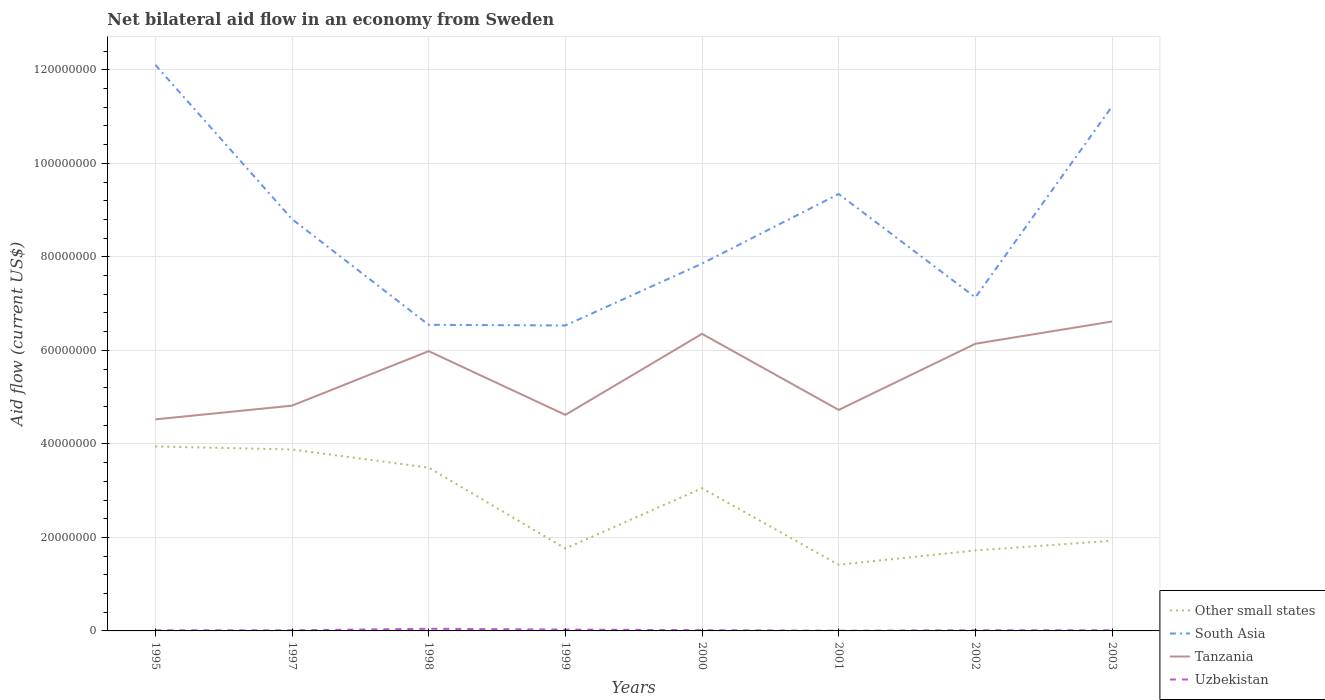Does the line corresponding to Uzbekistan intersect with the line corresponding to South Asia?
Keep it short and to the point. No. Across all years, what is the maximum net bilateral aid flow in Uzbekistan?
Provide a succinct answer. 4.00e+04. What is the total net bilateral aid flow in Other small states in the graph?
Offer a terse response. 1.73e+07. What is the difference between the highest and the second highest net bilateral aid flow in Tanzania?
Make the answer very short. 2.09e+07. Is the net bilateral aid flow in Uzbekistan strictly greater than the net bilateral aid flow in South Asia over the years?
Ensure brevity in your answer.  Yes. What is the difference between two consecutive major ticks on the Y-axis?
Give a very brief answer. 2.00e+07. Are the values on the major ticks of Y-axis written in scientific E-notation?
Your response must be concise. No. Does the graph contain grids?
Provide a short and direct response. Yes. Where does the legend appear in the graph?
Provide a short and direct response. Bottom right. How many legend labels are there?
Offer a very short reply. 4. How are the legend labels stacked?
Offer a very short reply. Vertical. What is the title of the graph?
Give a very brief answer. Net bilateral aid flow in an economy from Sweden. Does "Kazakhstan" appear as one of the legend labels in the graph?
Make the answer very short. No. What is the label or title of the X-axis?
Keep it short and to the point. Years. What is the Aid flow (current US$) in Other small states in 1995?
Keep it short and to the point. 3.95e+07. What is the Aid flow (current US$) of South Asia in 1995?
Make the answer very short. 1.21e+08. What is the Aid flow (current US$) in Tanzania in 1995?
Give a very brief answer. 4.52e+07. What is the Aid flow (current US$) of Uzbekistan in 1995?
Keep it short and to the point. 1.40e+05. What is the Aid flow (current US$) of Other small states in 1997?
Ensure brevity in your answer.  3.88e+07. What is the Aid flow (current US$) in South Asia in 1997?
Ensure brevity in your answer.  8.81e+07. What is the Aid flow (current US$) in Tanzania in 1997?
Your answer should be compact. 4.82e+07. What is the Aid flow (current US$) in Uzbekistan in 1997?
Give a very brief answer. 1.30e+05. What is the Aid flow (current US$) in Other small states in 1998?
Your answer should be very brief. 3.49e+07. What is the Aid flow (current US$) of South Asia in 1998?
Provide a short and direct response. 6.55e+07. What is the Aid flow (current US$) of Tanzania in 1998?
Provide a succinct answer. 5.98e+07. What is the Aid flow (current US$) in Uzbekistan in 1998?
Offer a terse response. 4.60e+05. What is the Aid flow (current US$) in Other small states in 1999?
Make the answer very short. 1.76e+07. What is the Aid flow (current US$) in South Asia in 1999?
Your answer should be very brief. 6.53e+07. What is the Aid flow (current US$) in Tanzania in 1999?
Provide a succinct answer. 4.62e+07. What is the Aid flow (current US$) in Other small states in 2000?
Your response must be concise. 3.05e+07. What is the Aid flow (current US$) of South Asia in 2000?
Give a very brief answer. 7.86e+07. What is the Aid flow (current US$) in Tanzania in 2000?
Keep it short and to the point. 6.35e+07. What is the Aid flow (current US$) in Uzbekistan in 2000?
Offer a very short reply. 1.60e+05. What is the Aid flow (current US$) in Other small states in 2001?
Give a very brief answer. 1.42e+07. What is the Aid flow (current US$) of South Asia in 2001?
Your answer should be very brief. 9.34e+07. What is the Aid flow (current US$) in Tanzania in 2001?
Offer a terse response. 4.73e+07. What is the Aid flow (current US$) of Other small states in 2002?
Your answer should be very brief. 1.72e+07. What is the Aid flow (current US$) in South Asia in 2002?
Provide a short and direct response. 7.13e+07. What is the Aid flow (current US$) in Tanzania in 2002?
Your response must be concise. 6.14e+07. What is the Aid flow (current US$) of Other small states in 2003?
Provide a short and direct response. 1.93e+07. What is the Aid flow (current US$) of South Asia in 2003?
Provide a short and direct response. 1.12e+08. What is the Aid flow (current US$) in Tanzania in 2003?
Your answer should be compact. 6.62e+07. What is the Aid flow (current US$) of Uzbekistan in 2003?
Offer a very short reply. 1.40e+05. Across all years, what is the maximum Aid flow (current US$) in Other small states?
Provide a short and direct response. 3.95e+07. Across all years, what is the maximum Aid flow (current US$) in South Asia?
Give a very brief answer. 1.21e+08. Across all years, what is the maximum Aid flow (current US$) of Tanzania?
Provide a succinct answer. 6.62e+07. Across all years, what is the minimum Aid flow (current US$) of Other small states?
Make the answer very short. 1.42e+07. Across all years, what is the minimum Aid flow (current US$) of South Asia?
Your answer should be compact. 6.53e+07. Across all years, what is the minimum Aid flow (current US$) in Tanzania?
Offer a very short reply. 4.52e+07. Across all years, what is the minimum Aid flow (current US$) in Uzbekistan?
Make the answer very short. 4.00e+04. What is the total Aid flow (current US$) of Other small states in the graph?
Ensure brevity in your answer.  2.12e+08. What is the total Aid flow (current US$) in South Asia in the graph?
Ensure brevity in your answer.  6.95e+08. What is the total Aid flow (current US$) of Tanzania in the graph?
Ensure brevity in your answer.  4.38e+08. What is the total Aid flow (current US$) of Uzbekistan in the graph?
Offer a terse response. 1.50e+06. What is the difference between the Aid flow (current US$) in Other small states in 1995 and that in 1997?
Offer a terse response. 6.50e+05. What is the difference between the Aid flow (current US$) of South Asia in 1995 and that in 1997?
Your response must be concise. 3.30e+07. What is the difference between the Aid flow (current US$) of Tanzania in 1995 and that in 1997?
Your answer should be very brief. -2.93e+06. What is the difference between the Aid flow (current US$) of Other small states in 1995 and that in 1998?
Provide a short and direct response. 4.53e+06. What is the difference between the Aid flow (current US$) of South Asia in 1995 and that in 1998?
Provide a succinct answer. 5.56e+07. What is the difference between the Aid flow (current US$) in Tanzania in 1995 and that in 1998?
Provide a succinct answer. -1.46e+07. What is the difference between the Aid flow (current US$) of Uzbekistan in 1995 and that in 1998?
Provide a succinct answer. -3.20e+05. What is the difference between the Aid flow (current US$) in Other small states in 1995 and that in 1999?
Keep it short and to the point. 2.18e+07. What is the difference between the Aid flow (current US$) in South Asia in 1995 and that in 1999?
Offer a very short reply. 5.57e+07. What is the difference between the Aid flow (current US$) in Tanzania in 1995 and that in 1999?
Offer a terse response. -9.60e+05. What is the difference between the Aid flow (current US$) in Uzbekistan in 1995 and that in 1999?
Offer a terse response. -1.50e+05. What is the difference between the Aid flow (current US$) of Other small states in 1995 and that in 2000?
Your response must be concise. 8.94e+06. What is the difference between the Aid flow (current US$) of South Asia in 1995 and that in 2000?
Your response must be concise. 4.25e+07. What is the difference between the Aid flow (current US$) in Tanzania in 1995 and that in 2000?
Your response must be concise. -1.83e+07. What is the difference between the Aid flow (current US$) of Other small states in 1995 and that in 2001?
Offer a terse response. 2.53e+07. What is the difference between the Aid flow (current US$) in South Asia in 1995 and that in 2001?
Keep it short and to the point. 2.76e+07. What is the difference between the Aid flow (current US$) in Tanzania in 1995 and that in 2001?
Make the answer very short. -2.02e+06. What is the difference between the Aid flow (current US$) in Uzbekistan in 1995 and that in 2001?
Your answer should be compact. 1.00e+05. What is the difference between the Aid flow (current US$) in Other small states in 1995 and that in 2002?
Ensure brevity in your answer.  2.22e+07. What is the difference between the Aid flow (current US$) of South Asia in 1995 and that in 2002?
Provide a succinct answer. 4.97e+07. What is the difference between the Aid flow (current US$) of Tanzania in 1995 and that in 2002?
Offer a terse response. -1.62e+07. What is the difference between the Aid flow (current US$) in Other small states in 1995 and that in 2003?
Provide a succinct answer. 2.02e+07. What is the difference between the Aid flow (current US$) of South Asia in 1995 and that in 2003?
Provide a succinct answer. 8.89e+06. What is the difference between the Aid flow (current US$) in Tanzania in 1995 and that in 2003?
Your answer should be compact. -2.09e+07. What is the difference between the Aid flow (current US$) of Uzbekistan in 1995 and that in 2003?
Your answer should be very brief. 0. What is the difference between the Aid flow (current US$) of Other small states in 1997 and that in 1998?
Provide a short and direct response. 3.88e+06. What is the difference between the Aid flow (current US$) of South Asia in 1997 and that in 1998?
Provide a succinct answer. 2.26e+07. What is the difference between the Aid flow (current US$) of Tanzania in 1997 and that in 1998?
Offer a terse response. -1.17e+07. What is the difference between the Aid flow (current US$) of Uzbekistan in 1997 and that in 1998?
Ensure brevity in your answer.  -3.30e+05. What is the difference between the Aid flow (current US$) in Other small states in 1997 and that in 1999?
Ensure brevity in your answer.  2.12e+07. What is the difference between the Aid flow (current US$) of South Asia in 1997 and that in 1999?
Your response must be concise. 2.28e+07. What is the difference between the Aid flow (current US$) of Tanzania in 1997 and that in 1999?
Provide a short and direct response. 1.97e+06. What is the difference between the Aid flow (current US$) of Other small states in 1997 and that in 2000?
Your answer should be compact. 8.29e+06. What is the difference between the Aid flow (current US$) in South Asia in 1997 and that in 2000?
Provide a short and direct response. 9.51e+06. What is the difference between the Aid flow (current US$) in Tanzania in 1997 and that in 2000?
Your answer should be compact. -1.54e+07. What is the difference between the Aid flow (current US$) in Uzbekistan in 1997 and that in 2000?
Your answer should be compact. -3.00e+04. What is the difference between the Aid flow (current US$) in Other small states in 1997 and that in 2001?
Offer a very short reply. 2.47e+07. What is the difference between the Aid flow (current US$) in South Asia in 1997 and that in 2001?
Provide a succinct answer. -5.37e+06. What is the difference between the Aid flow (current US$) of Tanzania in 1997 and that in 2001?
Offer a terse response. 9.10e+05. What is the difference between the Aid flow (current US$) in Uzbekistan in 1997 and that in 2001?
Your response must be concise. 9.00e+04. What is the difference between the Aid flow (current US$) in Other small states in 1997 and that in 2002?
Make the answer very short. 2.16e+07. What is the difference between the Aid flow (current US$) of South Asia in 1997 and that in 2002?
Your answer should be compact. 1.67e+07. What is the difference between the Aid flow (current US$) of Tanzania in 1997 and that in 2002?
Your answer should be very brief. -1.32e+07. What is the difference between the Aid flow (current US$) of Other small states in 1997 and that in 2003?
Make the answer very short. 1.95e+07. What is the difference between the Aid flow (current US$) in South Asia in 1997 and that in 2003?
Give a very brief answer. -2.41e+07. What is the difference between the Aid flow (current US$) in Tanzania in 1997 and that in 2003?
Provide a succinct answer. -1.80e+07. What is the difference between the Aid flow (current US$) of Other small states in 1998 and that in 1999?
Offer a very short reply. 1.73e+07. What is the difference between the Aid flow (current US$) of South Asia in 1998 and that in 1999?
Your answer should be compact. 1.40e+05. What is the difference between the Aid flow (current US$) of Tanzania in 1998 and that in 1999?
Provide a succinct answer. 1.36e+07. What is the difference between the Aid flow (current US$) in Uzbekistan in 1998 and that in 1999?
Provide a succinct answer. 1.70e+05. What is the difference between the Aid flow (current US$) in Other small states in 1998 and that in 2000?
Provide a short and direct response. 4.41e+06. What is the difference between the Aid flow (current US$) in South Asia in 1998 and that in 2000?
Keep it short and to the point. -1.31e+07. What is the difference between the Aid flow (current US$) in Tanzania in 1998 and that in 2000?
Keep it short and to the point. -3.70e+06. What is the difference between the Aid flow (current US$) in Other small states in 1998 and that in 2001?
Provide a succinct answer. 2.08e+07. What is the difference between the Aid flow (current US$) in South Asia in 1998 and that in 2001?
Ensure brevity in your answer.  -2.80e+07. What is the difference between the Aid flow (current US$) of Tanzania in 1998 and that in 2001?
Keep it short and to the point. 1.26e+07. What is the difference between the Aid flow (current US$) in Uzbekistan in 1998 and that in 2001?
Your response must be concise. 4.20e+05. What is the difference between the Aid flow (current US$) of Other small states in 1998 and that in 2002?
Ensure brevity in your answer.  1.77e+07. What is the difference between the Aid flow (current US$) in South Asia in 1998 and that in 2002?
Your answer should be very brief. -5.87e+06. What is the difference between the Aid flow (current US$) of Tanzania in 1998 and that in 2002?
Your answer should be compact. -1.58e+06. What is the difference between the Aid flow (current US$) of Other small states in 1998 and that in 2003?
Your answer should be very brief. 1.56e+07. What is the difference between the Aid flow (current US$) of South Asia in 1998 and that in 2003?
Offer a very short reply. -4.67e+07. What is the difference between the Aid flow (current US$) in Tanzania in 1998 and that in 2003?
Offer a very short reply. -6.34e+06. What is the difference between the Aid flow (current US$) of Other small states in 1999 and that in 2000?
Provide a short and direct response. -1.29e+07. What is the difference between the Aid flow (current US$) in South Asia in 1999 and that in 2000?
Your response must be concise. -1.32e+07. What is the difference between the Aid flow (current US$) of Tanzania in 1999 and that in 2000?
Your answer should be very brief. -1.73e+07. What is the difference between the Aid flow (current US$) of Uzbekistan in 1999 and that in 2000?
Your answer should be compact. 1.30e+05. What is the difference between the Aid flow (current US$) in Other small states in 1999 and that in 2001?
Ensure brevity in your answer.  3.48e+06. What is the difference between the Aid flow (current US$) of South Asia in 1999 and that in 2001?
Keep it short and to the point. -2.81e+07. What is the difference between the Aid flow (current US$) in Tanzania in 1999 and that in 2001?
Make the answer very short. -1.06e+06. What is the difference between the Aid flow (current US$) in Uzbekistan in 1999 and that in 2001?
Your answer should be very brief. 2.50e+05. What is the difference between the Aid flow (current US$) in South Asia in 1999 and that in 2002?
Your answer should be very brief. -6.01e+06. What is the difference between the Aid flow (current US$) in Tanzania in 1999 and that in 2002?
Provide a succinct answer. -1.52e+07. What is the difference between the Aid flow (current US$) in Other small states in 1999 and that in 2003?
Your response must be concise. -1.65e+06. What is the difference between the Aid flow (current US$) in South Asia in 1999 and that in 2003?
Ensure brevity in your answer.  -4.68e+07. What is the difference between the Aid flow (current US$) of Tanzania in 1999 and that in 2003?
Your answer should be very brief. -2.00e+07. What is the difference between the Aid flow (current US$) in Uzbekistan in 1999 and that in 2003?
Offer a terse response. 1.50e+05. What is the difference between the Aid flow (current US$) in Other small states in 2000 and that in 2001?
Make the answer very short. 1.64e+07. What is the difference between the Aid flow (current US$) in South Asia in 2000 and that in 2001?
Give a very brief answer. -1.49e+07. What is the difference between the Aid flow (current US$) in Tanzania in 2000 and that in 2001?
Keep it short and to the point. 1.63e+07. What is the difference between the Aid flow (current US$) in Other small states in 2000 and that in 2002?
Ensure brevity in your answer.  1.33e+07. What is the difference between the Aid flow (current US$) in South Asia in 2000 and that in 2002?
Keep it short and to the point. 7.23e+06. What is the difference between the Aid flow (current US$) of Tanzania in 2000 and that in 2002?
Offer a terse response. 2.12e+06. What is the difference between the Aid flow (current US$) in Uzbekistan in 2000 and that in 2002?
Your answer should be very brief. 2.00e+04. What is the difference between the Aid flow (current US$) in Other small states in 2000 and that in 2003?
Your response must be concise. 1.12e+07. What is the difference between the Aid flow (current US$) in South Asia in 2000 and that in 2003?
Keep it short and to the point. -3.36e+07. What is the difference between the Aid flow (current US$) in Tanzania in 2000 and that in 2003?
Provide a succinct answer. -2.64e+06. What is the difference between the Aid flow (current US$) of Uzbekistan in 2000 and that in 2003?
Offer a terse response. 2.00e+04. What is the difference between the Aid flow (current US$) of Other small states in 2001 and that in 2002?
Keep it short and to the point. -3.07e+06. What is the difference between the Aid flow (current US$) of South Asia in 2001 and that in 2002?
Offer a very short reply. 2.21e+07. What is the difference between the Aid flow (current US$) of Tanzania in 2001 and that in 2002?
Your answer should be very brief. -1.42e+07. What is the difference between the Aid flow (current US$) in Uzbekistan in 2001 and that in 2002?
Your answer should be very brief. -1.00e+05. What is the difference between the Aid flow (current US$) in Other small states in 2001 and that in 2003?
Make the answer very short. -5.13e+06. What is the difference between the Aid flow (current US$) of South Asia in 2001 and that in 2003?
Give a very brief answer. -1.87e+07. What is the difference between the Aid flow (current US$) of Tanzania in 2001 and that in 2003?
Your response must be concise. -1.89e+07. What is the difference between the Aid flow (current US$) in Other small states in 2002 and that in 2003?
Provide a succinct answer. -2.06e+06. What is the difference between the Aid flow (current US$) in South Asia in 2002 and that in 2003?
Provide a short and direct response. -4.08e+07. What is the difference between the Aid flow (current US$) in Tanzania in 2002 and that in 2003?
Provide a short and direct response. -4.76e+06. What is the difference between the Aid flow (current US$) of Other small states in 1995 and the Aid flow (current US$) of South Asia in 1997?
Your answer should be very brief. -4.86e+07. What is the difference between the Aid flow (current US$) of Other small states in 1995 and the Aid flow (current US$) of Tanzania in 1997?
Provide a short and direct response. -8.72e+06. What is the difference between the Aid flow (current US$) of Other small states in 1995 and the Aid flow (current US$) of Uzbekistan in 1997?
Offer a very short reply. 3.93e+07. What is the difference between the Aid flow (current US$) in South Asia in 1995 and the Aid flow (current US$) in Tanzania in 1997?
Your response must be concise. 7.29e+07. What is the difference between the Aid flow (current US$) in South Asia in 1995 and the Aid flow (current US$) in Uzbekistan in 1997?
Your answer should be compact. 1.21e+08. What is the difference between the Aid flow (current US$) in Tanzania in 1995 and the Aid flow (current US$) in Uzbekistan in 1997?
Provide a short and direct response. 4.51e+07. What is the difference between the Aid flow (current US$) of Other small states in 1995 and the Aid flow (current US$) of South Asia in 1998?
Offer a very short reply. -2.60e+07. What is the difference between the Aid flow (current US$) in Other small states in 1995 and the Aid flow (current US$) in Tanzania in 1998?
Make the answer very short. -2.04e+07. What is the difference between the Aid flow (current US$) of Other small states in 1995 and the Aid flow (current US$) of Uzbekistan in 1998?
Make the answer very short. 3.90e+07. What is the difference between the Aid flow (current US$) of South Asia in 1995 and the Aid flow (current US$) of Tanzania in 1998?
Your response must be concise. 6.12e+07. What is the difference between the Aid flow (current US$) in South Asia in 1995 and the Aid flow (current US$) in Uzbekistan in 1998?
Your answer should be very brief. 1.21e+08. What is the difference between the Aid flow (current US$) of Tanzania in 1995 and the Aid flow (current US$) of Uzbekistan in 1998?
Ensure brevity in your answer.  4.48e+07. What is the difference between the Aid flow (current US$) in Other small states in 1995 and the Aid flow (current US$) in South Asia in 1999?
Ensure brevity in your answer.  -2.59e+07. What is the difference between the Aid flow (current US$) of Other small states in 1995 and the Aid flow (current US$) of Tanzania in 1999?
Ensure brevity in your answer.  -6.75e+06. What is the difference between the Aid flow (current US$) of Other small states in 1995 and the Aid flow (current US$) of Uzbekistan in 1999?
Provide a short and direct response. 3.92e+07. What is the difference between the Aid flow (current US$) in South Asia in 1995 and the Aid flow (current US$) in Tanzania in 1999?
Keep it short and to the point. 7.49e+07. What is the difference between the Aid flow (current US$) of South Asia in 1995 and the Aid flow (current US$) of Uzbekistan in 1999?
Your answer should be compact. 1.21e+08. What is the difference between the Aid flow (current US$) in Tanzania in 1995 and the Aid flow (current US$) in Uzbekistan in 1999?
Your response must be concise. 4.50e+07. What is the difference between the Aid flow (current US$) in Other small states in 1995 and the Aid flow (current US$) in South Asia in 2000?
Provide a succinct answer. -3.91e+07. What is the difference between the Aid flow (current US$) in Other small states in 1995 and the Aid flow (current US$) in Tanzania in 2000?
Offer a very short reply. -2.41e+07. What is the difference between the Aid flow (current US$) in Other small states in 1995 and the Aid flow (current US$) in Uzbekistan in 2000?
Give a very brief answer. 3.93e+07. What is the difference between the Aid flow (current US$) of South Asia in 1995 and the Aid flow (current US$) of Tanzania in 2000?
Provide a short and direct response. 5.75e+07. What is the difference between the Aid flow (current US$) in South Asia in 1995 and the Aid flow (current US$) in Uzbekistan in 2000?
Your response must be concise. 1.21e+08. What is the difference between the Aid flow (current US$) in Tanzania in 1995 and the Aid flow (current US$) in Uzbekistan in 2000?
Keep it short and to the point. 4.51e+07. What is the difference between the Aid flow (current US$) in Other small states in 1995 and the Aid flow (current US$) in South Asia in 2001?
Your answer should be compact. -5.40e+07. What is the difference between the Aid flow (current US$) of Other small states in 1995 and the Aid flow (current US$) of Tanzania in 2001?
Ensure brevity in your answer.  -7.81e+06. What is the difference between the Aid flow (current US$) of Other small states in 1995 and the Aid flow (current US$) of Uzbekistan in 2001?
Your answer should be compact. 3.94e+07. What is the difference between the Aid flow (current US$) in South Asia in 1995 and the Aid flow (current US$) in Tanzania in 2001?
Your answer should be very brief. 7.38e+07. What is the difference between the Aid flow (current US$) of South Asia in 1995 and the Aid flow (current US$) of Uzbekistan in 2001?
Offer a very short reply. 1.21e+08. What is the difference between the Aid flow (current US$) of Tanzania in 1995 and the Aid flow (current US$) of Uzbekistan in 2001?
Provide a short and direct response. 4.52e+07. What is the difference between the Aid flow (current US$) of Other small states in 1995 and the Aid flow (current US$) of South Asia in 2002?
Your answer should be compact. -3.19e+07. What is the difference between the Aid flow (current US$) of Other small states in 1995 and the Aid flow (current US$) of Tanzania in 2002?
Keep it short and to the point. -2.20e+07. What is the difference between the Aid flow (current US$) in Other small states in 1995 and the Aid flow (current US$) in Uzbekistan in 2002?
Your response must be concise. 3.93e+07. What is the difference between the Aid flow (current US$) of South Asia in 1995 and the Aid flow (current US$) of Tanzania in 2002?
Your answer should be compact. 5.96e+07. What is the difference between the Aid flow (current US$) of South Asia in 1995 and the Aid flow (current US$) of Uzbekistan in 2002?
Offer a terse response. 1.21e+08. What is the difference between the Aid flow (current US$) of Tanzania in 1995 and the Aid flow (current US$) of Uzbekistan in 2002?
Offer a very short reply. 4.51e+07. What is the difference between the Aid flow (current US$) in Other small states in 1995 and the Aid flow (current US$) in South Asia in 2003?
Your answer should be compact. -7.27e+07. What is the difference between the Aid flow (current US$) of Other small states in 1995 and the Aid flow (current US$) of Tanzania in 2003?
Provide a short and direct response. -2.67e+07. What is the difference between the Aid flow (current US$) of Other small states in 1995 and the Aid flow (current US$) of Uzbekistan in 2003?
Offer a very short reply. 3.93e+07. What is the difference between the Aid flow (current US$) in South Asia in 1995 and the Aid flow (current US$) in Tanzania in 2003?
Your answer should be very brief. 5.49e+07. What is the difference between the Aid flow (current US$) in South Asia in 1995 and the Aid flow (current US$) in Uzbekistan in 2003?
Offer a terse response. 1.21e+08. What is the difference between the Aid flow (current US$) in Tanzania in 1995 and the Aid flow (current US$) in Uzbekistan in 2003?
Your answer should be compact. 4.51e+07. What is the difference between the Aid flow (current US$) of Other small states in 1997 and the Aid flow (current US$) of South Asia in 1998?
Offer a very short reply. -2.67e+07. What is the difference between the Aid flow (current US$) in Other small states in 1997 and the Aid flow (current US$) in Tanzania in 1998?
Your answer should be compact. -2.10e+07. What is the difference between the Aid flow (current US$) in Other small states in 1997 and the Aid flow (current US$) in Uzbekistan in 1998?
Ensure brevity in your answer.  3.84e+07. What is the difference between the Aid flow (current US$) in South Asia in 1997 and the Aid flow (current US$) in Tanzania in 1998?
Your answer should be very brief. 2.82e+07. What is the difference between the Aid flow (current US$) in South Asia in 1997 and the Aid flow (current US$) in Uzbekistan in 1998?
Keep it short and to the point. 8.76e+07. What is the difference between the Aid flow (current US$) of Tanzania in 1997 and the Aid flow (current US$) of Uzbekistan in 1998?
Offer a very short reply. 4.77e+07. What is the difference between the Aid flow (current US$) in Other small states in 1997 and the Aid flow (current US$) in South Asia in 1999?
Keep it short and to the point. -2.65e+07. What is the difference between the Aid flow (current US$) of Other small states in 1997 and the Aid flow (current US$) of Tanzania in 1999?
Make the answer very short. -7.40e+06. What is the difference between the Aid flow (current US$) in Other small states in 1997 and the Aid flow (current US$) in Uzbekistan in 1999?
Keep it short and to the point. 3.85e+07. What is the difference between the Aid flow (current US$) in South Asia in 1997 and the Aid flow (current US$) in Tanzania in 1999?
Your response must be concise. 4.19e+07. What is the difference between the Aid flow (current US$) in South Asia in 1997 and the Aid flow (current US$) in Uzbekistan in 1999?
Your answer should be very brief. 8.78e+07. What is the difference between the Aid flow (current US$) in Tanzania in 1997 and the Aid flow (current US$) in Uzbekistan in 1999?
Ensure brevity in your answer.  4.79e+07. What is the difference between the Aid flow (current US$) of Other small states in 1997 and the Aid flow (current US$) of South Asia in 2000?
Provide a succinct answer. -3.98e+07. What is the difference between the Aid flow (current US$) in Other small states in 1997 and the Aid flow (current US$) in Tanzania in 2000?
Make the answer very short. -2.47e+07. What is the difference between the Aid flow (current US$) of Other small states in 1997 and the Aid flow (current US$) of Uzbekistan in 2000?
Offer a terse response. 3.86e+07. What is the difference between the Aid flow (current US$) in South Asia in 1997 and the Aid flow (current US$) in Tanzania in 2000?
Offer a terse response. 2.45e+07. What is the difference between the Aid flow (current US$) of South Asia in 1997 and the Aid flow (current US$) of Uzbekistan in 2000?
Your answer should be very brief. 8.79e+07. What is the difference between the Aid flow (current US$) of Tanzania in 1997 and the Aid flow (current US$) of Uzbekistan in 2000?
Your answer should be compact. 4.80e+07. What is the difference between the Aid flow (current US$) of Other small states in 1997 and the Aid flow (current US$) of South Asia in 2001?
Your response must be concise. -5.46e+07. What is the difference between the Aid flow (current US$) of Other small states in 1997 and the Aid flow (current US$) of Tanzania in 2001?
Your response must be concise. -8.46e+06. What is the difference between the Aid flow (current US$) in Other small states in 1997 and the Aid flow (current US$) in Uzbekistan in 2001?
Offer a terse response. 3.88e+07. What is the difference between the Aid flow (current US$) of South Asia in 1997 and the Aid flow (current US$) of Tanzania in 2001?
Make the answer very short. 4.08e+07. What is the difference between the Aid flow (current US$) in South Asia in 1997 and the Aid flow (current US$) in Uzbekistan in 2001?
Ensure brevity in your answer.  8.80e+07. What is the difference between the Aid flow (current US$) in Tanzania in 1997 and the Aid flow (current US$) in Uzbekistan in 2001?
Keep it short and to the point. 4.81e+07. What is the difference between the Aid flow (current US$) of Other small states in 1997 and the Aid flow (current US$) of South Asia in 2002?
Your answer should be compact. -3.25e+07. What is the difference between the Aid flow (current US$) in Other small states in 1997 and the Aid flow (current US$) in Tanzania in 2002?
Give a very brief answer. -2.26e+07. What is the difference between the Aid flow (current US$) in Other small states in 1997 and the Aid flow (current US$) in Uzbekistan in 2002?
Give a very brief answer. 3.87e+07. What is the difference between the Aid flow (current US$) in South Asia in 1997 and the Aid flow (current US$) in Tanzania in 2002?
Your answer should be compact. 2.67e+07. What is the difference between the Aid flow (current US$) of South Asia in 1997 and the Aid flow (current US$) of Uzbekistan in 2002?
Offer a very short reply. 8.79e+07. What is the difference between the Aid flow (current US$) of Tanzania in 1997 and the Aid flow (current US$) of Uzbekistan in 2002?
Your answer should be very brief. 4.80e+07. What is the difference between the Aid flow (current US$) in Other small states in 1997 and the Aid flow (current US$) in South Asia in 2003?
Keep it short and to the point. -7.34e+07. What is the difference between the Aid flow (current US$) in Other small states in 1997 and the Aid flow (current US$) in Tanzania in 2003?
Offer a terse response. -2.74e+07. What is the difference between the Aid flow (current US$) of Other small states in 1997 and the Aid flow (current US$) of Uzbekistan in 2003?
Provide a succinct answer. 3.87e+07. What is the difference between the Aid flow (current US$) of South Asia in 1997 and the Aid flow (current US$) of Tanzania in 2003?
Your answer should be very brief. 2.19e+07. What is the difference between the Aid flow (current US$) in South Asia in 1997 and the Aid flow (current US$) in Uzbekistan in 2003?
Your answer should be very brief. 8.79e+07. What is the difference between the Aid flow (current US$) of Tanzania in 1997 and the Aid flow (current US$) of Uzbekistan in 2003?
Provide a succinct answer. 4.80e+07. What is the difference between the Aid flow (current US$) in Other small states in 1998 and the Aid flow (current US$) in South Asia in 1999?
Ensure brevity in your answer.  -3.04e+07. What is the difference between the Aid flow (current US$) in Other small states in 1998 and the Aid flow (current US$) in Tanzania in 1999?
Provide a succinct answer. -1.13e+07. What is the difference between the Aid flow (current US$) of Other small states in 1998 and the Aid flow (current US$) of Uzbekistan in 1999?
Ensure brevity in your answer.  3.46e+07. What is the difference between the Aid flow (current US$) of South Asia in 1998 and the Aid flow (current US$) of Tanzania in 1999?
Give a very brief answer. 1.93e+07. What is the difference between the Aid flow (current US$) of South Asia in 1998 and the Aid flow (current US$) of Uzbekistan in 1999?
Keep it short and to the point. 6.52e+07. What is the difference between the Aid flow (current US$) in Tanzania in 1998 and the Aid flow (current US$) in Uzbekistan in 1999?
Provide a succinct answer. 5.96e+07. What is the difference between the Aid flow (current US$) of Other small states in 1998 and the Aid flow (current US$) of South Asia in 2000?
Your answer should be compact. -4.36e+07. What is the difference between the Aid flow (current US$) in Other small states in 1998 and the Aid flow (current US$) in Tanzania in 2000?
Make the answer very short. -2.86e+07. What is the difference between the Aid flow (current US$) of Other small states in 1998 and the Aid flow (current US$) of Uzbekistan in 2000?
Provide a short and direct response. 3.48e+07. What is the difference between the Aid flow (current US$) in South Asia in 1998 and the Aid flow (current US$) in Tanzania in 2000?
Keep it short and to the point. 1.93e+06. What is the difference between the Aid flow (current US$) in South Asia in 1998 and the Aid flow (current US$) in Uzbekistan in 2000?
Give a very brief answer. 6.53e+07. What is the difference between the Aid flow (current US$) in Tanzania in 1998 and the Aid flow (current US$) in Uzbekistan in 2000?
Your response must be concise. 5.97e+07. What is the difference between the Aid flow (current US$) in Other small states in 1998 and the Aid flow (current US$) in South Asia in 2001?
Ensure brevity in your answer.  -5.85e+07. What is the difference between the Aid flow (current US$) in Other small states in 1998 and the Aid flow (current US$) in Tanzania in 2001?
Make the answer very short. -1.23e+07. What is the difference between the Aid flow (current US$) of Other small states in 1998 and the Aid flow (current US$) of Uzbekistan in 2001?
Your answer should be very brief. 3.49e+07. What is the difference between the Aid flow (current US$) of South Asia in 1998 and the Aid flow (current US$) of Tanzania in 2001?
Ensure brevity in your answer.  1.82e+07. What is the difference between the Aid flow (current US$) in South Asia in 1998 and the Aid flow (current US$) in Uzbekistan in 2001?
Give a very brief answer. 6.54e+07. What is the difference between the Aid flow (current US$) in Tanzania in 1998 and the Aid flow (current US$) in Uzbekistan in 2001?
Provide a succinct answer. 5.98e+07. What is the difference between the Aid flow (current US$) of Other small states in 1998 and the Aid flow (current US$) of South Asia in 2002?
Offer a terse response. -3.64e+07. What is the difference between the Aid flow (current US$) of Other small states in 1998 and the Aid flow (current US$) of Tanzania in 2002?
Give a very brief answer. -2.65e+07. What is the difference between the Aid flow (current US$) in Other small states in 1998 and the Aid flow (current US$) in Uzbekistan in 2002?
Give a very brief answer. 3.48e+07. What is the difference between the Aid flow (current US$) of South Asia in 1998 and the Aid flow (current US$) of Tanzania in 2002?
Offer a very short reply. 4.05e+06. What is the difference between the Aid flow (current US$) in South Asia in 1998 and the Aid flow (current US$) in Uzbekistan in 2002?
Offer a very short reply. 6.53e+07. What is the difference between the Aid flow (current US$) of Tanzania in 1998 and the Aid flow (current US$) of Uzbekistan in 2002?
Make the answer very short. 5.97e+07. What is the difference between the Aid flow (current US$) of Other small states in 1998 and the Aid flow (current US$) of South Asia in 2003?
Give a very brief answer. -7.72e+07. What is the difference between the Aid flow (current US$) of Other small states in 1998 and the Aid flow (current US$) of Tanzania in 2003?
Make the answer very short. -3.12e+07. What is the difference between the Aid flow (current US$) of Other small states in 1998 and the Aid flow (current US$) of Uzbekistan in 2003?
Make the answer very short. 3.48e+07. What is the difference between the Aid flow (current US$) of South Asia in 1998 and the Aid flow (current US$) of Tanzania in 2003?
Make the answer very short. -7.10e+05. What is the difference between the Aid flow (current US$) of South Asia in 1998 and the Aid flow (current US$) of Uzbekistan in 2003?
Provide a short and direct response. 6.53e+07. What is the difference between the Aid flow (current US$) in Tanzania in 1998 and the Aid flow (current US$) in Uzbekistan in 2003?
Your answer should be compact. 5.97e+07. What is the difference between the Aid flow (current US$) in Other small states in 1999 and the Aid flow (current US$) in South Asia in 2000?
Your answer should be very brief. -6.09e+07. What is the difference between the Aid flow (current US$) of Other small states in 1999 and the Aid flow (current US$) of Tanzania in 2000?
Offer a very short reply. -4.59e+07. What is the difference between the Aid flow (current US$) of Other small states in 1999 and the Aid flow (current US$) of Uzbekistan in 2000?
Ensure brevity in your answer.  1.75e+07. What is the difference between the Aid flow (current US$) in South Asia in 1999 and the Aid flow (current US$) in Tanzania in 2000?
Your answer should be very brief. 1.79e+06. What is the difference between the Aid flow (current US$) in South Asia in 1999 and the Aid flow (current US$) in Uzbekistan in 2000?
Make the answer very short. 6.52e+07. What is the difference between the Aid flow (current US$) of Tanzania in 1999 and the Aid flow (current US$) of Uzbekistan in 2000?
Ensure brevity in your answer.  4.60e+07. What is the difference between the Aid flow (current US$) in Other small states in 1999 and the Aid flow (current US$) in South Asia in 2001?
Offer a terse response. -7.58e+07. What is the difference between the Aid flow (current US$) of Other small states in 1999 and the Aid flow (current US$) of Tanzania in 2001?
Your answer should be compact. -2.96e+07. What is the difference between the Aid flow (current US$) in Other small states in 1999 and the Aid flow (current US$) in Uzbekistan in 2001?
Your answer should be compact. 1.76e+07. What is the difference between the Aid flow (current US$) in South Asia in 1999 and the Aid flow (current US$) in Tanzania in 2001?
Give a very brief answer. 1.81e+07. What is the difference between the Aid flow (current US$) of South Asia in 1999 and the Aid flow (current US$) of Uzbekistan in 2001?
Provide a short and direct response. 6.53e+07. What is the difference between the Aid flow (current US$) in Tanzania in 1999 and the Aid flow (current US$) in Uzbekistan in 2001?
Ensure brevity in your answer.  4.62e+07. What is the difference between the Aid flow (current US$) in Other small states in 1999 and the Aid flow (current US$) in South Asia in 2002?
Your answer should be very brief. -5.37e+07. What is the difference between the Aid flow (current US$) in Other small states in 1999 and the Aid flow (current US$) in Tanzania in 2002?
Ensure brevity in your answer.  -4.38e+07. What is the difference between the Aid flow (current US$) of Other small states in 1999 and the Aid flow (current US$) of Uzbekistan in 2002?
Provide a succinct answer. 1.75e+07. What is the difference between the Aid flow (current US$) of South Asia in 1999 and the Aid flow (current US$) of Tanzania in 2002?
Keep it short and to the point. 3.91e+06. What is the difference between the Aid flow (current US$) in South Asia in 1999 and the Aid flow (current US$) in Uzbekistan in 2002?
Your answer should be very brief. 6.52e+07. What is the difference between the Aid flow (current US$) of Tanzania in 1999 and the Aid flow (current US$) of Uzbekistan in 2002?
Make the answer very short. 4.61e+07. What is the difference between the Aid flow (current US$) of Other small states in 1999 and the Aid flow (current US$) of South Asia in 2003?
Provide a succinct answer. -9.46e+07. What is the difference between the Aid flow (current US$) of Other small states in 1999 and the Aid flow (current US$) of Tanzania in 2003?
Ensure brevity in your answer.  -4.86e+07. What is the difference between the Aid flow (current US$) of Other small states in 1999 and the Aid flow (current US$) of Uzbekistan in 2003?
Make the answer very short. 1.75e+07. What is the difference between the Aid flow (current US$) of South Asia in 1999 and the Aid flow (current US$) of Tanzania in 2003?
Keep it short and to the point. -8.50e+05. What is the difference between the Aid flow (current US$) of South Asia in 1999 and the Aid flow (current US$) of Uzbekistan in 2003?
Keep it short and to the point. 6.52e+07. What is the difference between the Aid flow (current US$) of Tanzania in 1999 and the Aid flow (current US$) of Uzbekistan in 2003?
Offer a terse response. 4.61e+07. What is the difference between the Aid flow (current US$) of Other small states in 2000 and the Aid flow (current US$) of South Asia in 2001?
Your answer should be very brief. -6.29e+07. What is the difference between the Aid flow (current US$) in Other small states in 2000 and the Aid flow (current US$) in Tanzania in 2001?
Offer a terse response. -1.68e+07. What is the difference between the Aid flow (current US$) in Other small states in 2000 and the Aid flow (current US$) in Uzbekistan in 2001?
Make the answer very short. 3.05e+07. What is the difference between the Aid flow (current US$) in South Asia in 2000 and the Aid flow (current US$) in Tanzania in 2001?
Give a very brief answer. 3.13e+07. What is the difference between the Aid flow (current US$) of South Asia in 2000 and the Aid flow (current US$) of Uzbekistan in 2001?
Provide a succinct answer. 7.85e+07. What is the difference between the Aid flow (current US$) in Tanzania in 2000 and the Aid flow (current US$) in Uzbekistan in 2001?
Give a very brief answer. 6.35e+07. What is the difference between the Aid flow (current US$) in Other small states in 2000 and the Aid flow (current US$) in South Asia in 2002?
Your answer should be very brief. -4.08e+07. What is the difference between the Aid flow (current US$) in Other small states in 2000 and the Aid flow (current US$) in Tanzania in 2002?
Provide a succinct answer. -3.09e+07. What is the difference between the Aid flow (current US$) of Other small states in 2000 and the Aid flow (current US$) of Uzbekistan in 2002?
Provide a short and direct response. 3.04e+07. What is the difference between the Aid flow (current US$) in South Asia in 2000 and the Aid flow (current US$) in Tanzania in 2002?
Offer a very short reply. 1.72e+07. What is the difference between the Aid flow (current US$) in South Asia in 2000 and the Aid flow (current US$) in Uzbekistan in 2002?
Your answer should be compact. 7.84e+07. What is the difference between the Aid flow (current US$) in Tanzania in 2000 and the Aid flow (current US$) in Uzbekistan in 2002?
Ensure brevity in your answer.  6.34e+07. What is the difference between the Aid flow (current US$) in Other small states in 2000 and the Aid flow (current US$) in South Asia in 2003?
Offer a terse response. -8.17e+07. What is the difference between the Aid flow (current US$) in Other small states in 2000 and the Aid flow (current US$) in Tanzania in 2003?
Ensure brevity in your answer.  -3.57e+07. What is the difference between the Aid flow (current US$) in Other small states in 2000 and the Aid flow (current US$) in Uzbekistan in 2003?
Offer a terse response. 3.04e+07. What is the difference between the Aid flow (current US$) in South Asia in 2000 and the Aid flow (current US$) in Tanzania in 2003?
Your answer should be compact. 1.24e+07. What is the difference between the Aid flow (current US$) of South Asia in 2000 and the Aid flow (current US$) of Uzbekistan in 2003?
Provide a succinct answer. 7.84e+07. What is the difference between the Aid flow (current US$) of Tanzania in 2000 and the Aid flow (current US$) of Uzbekistan in 2003?
Ensure brevity in your answer.  6.34e+07. What is the difference between the Aid flow (current US$) in Other small states in 2001 and the Aid flow (current US$) in South Asia in 2002?
Provide a short and direct response. -5.72e+07. What is the difference between the Aid flow (current US$) in Other small states in 2001 and the Aid flow (current US$) in Tanzania in 2002?
Keep it short and to the point. -4.73e+07. What is the difference between the Aid flow (current US$) of Other small states in 2001 and the Aid flow (current US$) of Uzbekistan in 2002?
Provide a succinct answer. 1.40e+07. What is the difference between the Aid flow (current US$) of South Asia in 2001 and the Aid flow (current US$) of Tanzania in 2002?
Give a very brief answer. 3.20e+07. What is the difference between the Aid flow (current US$) of South Asia in 2001 and the Aid flow (current US$) of Uzbekistan in 2002?
Provide a short and direct response. 9.33e+07. What is the difference between the Aid flow (current US$) of Tanzania in 2001 and the Aid flow (current US$) of Uzbekistan in 2002?
Keep it short and to the point. 4.71e+07. What is the difference between the Aid flow (current US$) in Other small states in 2001 and the Aid flow (current US$) in South Asia in 2003?
Offer a very short reply. -9.80e+07. What is the difference between the Aid flow (current US$) in Other small states in 2001 and the Aid flow (current US$) in Tanzania in 2003?
Keep it short and to the point. -5.20e+07. What is the difference between the Aid flow (current US$) in Other small states in 2001 and the Aid flow (current US$) in Uzbekistan in 2003?
Your answer should be compact. 1.40e+07. What is the difference between the Aid flow (current US$) in South Asia in 2001 and the Aid flow (current US$) in Tanzania in 2003?
Ensure brevity in your answer.  2.73e+07. What is the difference between the Aid flow (current US$) of South Asia in 2001 and the Aid flow (current US$) of Uzbekistan in 2003?
Offer a very short reply. 9.33e+07. What is the difference between the Aid flow (current US$) of Tanzania in 2001 and the Aid flow (current US$) of Uzbekistan in 2003?
Provide a succinct answer. 4.71e+07. What is the difference between the Aid flow (current US$) in Other small states in 2002 and the Aid flow (current US$) in South Asia in 2003?
Your response must be concise. -9.50e+07. What is the difference between the Aid flow (current US$) of Other small states in 2002 and the Aid flow (current US$) of Tanzania in 2003?
Provide a short and direct response. -4.90e+07. What is the difference between the Aid flow (current US$) in Other small states in 2002 and the Aid flow (current US$) in Uzbekistan in 2003?
Provide a succinct answer. 1.71e+07. What is the difference between the Aid flow (current US$) in South Asia in 2002 and the Aid flow (current US$) in Tanzania in 2003?
Your answer should be compact. 5.16e+06. What is the difference between the Aid flow (current US$) of South Asia in 2002 and the Aid flow (current US$) of Uzbekistan in 2003?
Offer a terse response. 7.12e+07. What is the difference between the Aid flow (current US$) in Tanzania in 2002 and the Aid flow (current US$) in Uzbekistan in 2003?
Ensure brevity in your answer.  6.13e+07. What is the average Aid flow (current US$) in Other small states per year?
Provide a short and direct response. 2.65e+07. What is the average Aid flow (current US$) in South Asia per year?
Provide a succinct answer. 8.69e+07. What is the average Aid flow (current US$) of Tanzania per year?
Your answer should be compact. 5.47e+07. What is the average Aid flow (current US$) of Uzbekistan per year?
Make the answer very short. 1.88e+05. In the year 1995, what is the difference between the Aid flow (current US$) of Other small states and Aid flow (current US$) of South Asia?
Provide a succinct answer. -8.16e+07. In the year 1995, what is the difference between the Aid flow (current US$) in Other small states and Aid flow (current US$) in Tanzania?
Your answer should be very brief. -5.79e+06. In the year 1995, what is the difference between the Aid flow (current US$) in Other small states and Aid flow (current US$) in Uzbekistan?
Provide a short and direct response. 3.93e+07. In the year 1995, what is the difference between the Aid flow (current US$) in South Asia and Aid flow (current US$) in Tanzania?
Ensure brevity in your answer.  7.58e+07. In the year 1995, what is the difference between the Aid flow (current US$) of South Asia and Aid flow (current US$) of Uzbekistan?
Give a very brief answer. 1.21e+08. In the year 1995, what is the difference between the Aid flow (current US$) in Tanzania and Aid flow (current US$) in Uzbekistan?
Provide a succinct answer. 4.51e+07. In the year 1997, what is the difference between the Aid flow (current US$) of Other small states and Aid flow (current US$) of South Asia?
Offer a very short reply. -4.93e+07. In the year 1997, what is the difference between the Aid flow (current US$) in Other small states and Aid flow (current US$) in Tanzania?
Provide a succinct answer. -9.37e+06. In the year 1997, what is the difference between the Aid flow (current US$) of Other small states and Aid flow (current US$) of Uzbekistan?
Offer a very short reply. 3.87e+07. In the year 1997, what is the difference between the Aid flow (current US$) in South Asia and Aid flow (current US$) in Tanzania?
Offer a terse response. 3.99e+07. In the year 1997, what is the difference between the Aid flow (current US$) of South Asia and Aid flow (current US$) of Uzbekistan?
Ensure brevity in your answer.  8.80e+07. In the year 1997, what is the difference between the Aid flow (current US$) in Tanzania and Aid flow (current US$) in Uzbekistan?
Provide a succinct answer. 4.80e+07. In the year 1998, what is the difference between the Aid flow (current US$) of Other small states and Aid flow (current US$) of South Asia?
Provide a succinct answer. -3.05e+07. In the year 1998, what is the difference between the Aid flow (current US$) of Other small states and Aid flow (current US$) of Tanzania?
Keep it short and to the point. -2.49e+07. In the year 1998, what is the difference between the Aid flow (current US$) in Other small states and Aid flow (current US$) in Uzbekistan?
Keep it short and to the point. 3.45e+07. In the year 1998, what is the difference between the Aid flow (current US$) in South Asia and Aid flow (current US$) in Tanzania?
Make the answer very short. 5.63e+06. In the year 1998, what is the difference between the Aid flow (current US$) of South Asia and Aid flow (current US$) of Uzbekistan?
Provide a short and direct response. 6.50e+07. In the year 1998, what is the difference between the Aid flow (current US$) of Tanzania and Aid flow (current US$) of Uzbekistan?
Give a very brief answer. 5.94e+07. In the year 1999, what is the difference between the Aid flow (current US$) of Other small states and Aid flow (current US$) of South Asia?
Offer a very short reply. -4.77e+07. In the year 1999, what is the difference between the Aid flow (current US$) in Other small states and Aid flow (current US$) in Tanzania?
Provide a succinct answer. -2.86e+07. In the year 1999, what is the difference between the Aid flow (current US$) of Other small states and Aid flow (current US$) of Uzbekistan?
Your answer should be very brief. 1.73e+07. In the year 1999, what is the difference between the Aid flow (current US$) in South Asia and Aid flow (current US$) in Tanzania?
Provide a succinct answer. 1.91e+07. In the year 1999, what is the difference between the Aid flow (current US$) of South Asia and Aid flow (current US$) of Uzbekistan?
Ensure brevity in your answer.  6.50e+07. In the year 1999, what is the difference between the Aid flow (current US$) in Tanzania and Aid flow (current US$) in Uzbekistan?
Give a very brief answer. 4.59e+07. In the year 2000, what is the difference between the Aid flow (current US$) in Other small states and Aid flow (current US$) in South Asia?
Offer a very short reply. -4.80e+07. In the year 2000, what is the difference between the Aid flow (current US$) of Other small states and Aid flow (current US$) of Tanzania?
Give a very brief answer. -3.30e+07. In the year 2000, what is the difference between the Aid flow (current US$) of Other small states and Aid flow (current US$) of Uzbekistan?
Your response must be concise. 3.04e+07. In the year 2000, what is the difference between the Aid flow (current US$) in South Asia and Aid flow (current US$) in Tanzania?
Provide a succinct answer. 1.50e+07. In the year 2000, what is the difference between the Aid flow (current US$) of South Asia and Aid flow (current US$) of Uzbekistan?
Your answer should be very brief. 7.84e+07. In the year 2000, what is the difference between the Aid flow (current US$) in Tanzania and Aid flow (current US$) in Uzbekistan?
Offer a terse response. 6.34e+07. In the year 2001, what is the difference between the Aid flow (current US$) of Other small states and Aid flow (current US$) of South Asia?
Give a very brief answer. -7.93e+07. In the year 2001, what is the difference between the Aid flow (current US$) in Other small states and Aid flow (current US$) in Tanzania?
Provide a succinct answer. -3.31e+07. In the year 2001, what is the difference between the Aid flow (current US$) of Other small states and Aid flow (current US$) of Uzbekistan?
Offer a terse response. 1.41e+07. In the year 2001, what is the difference between the Aid flow (current US$) in South Asia and Aid flow (current US$) in Tanzania?
Keep it short and to the point. 4.62e+07. In the year 2001, what is the difference between the Aid flow (current US$) in South Asia and Aid flow (current US$) in Uzbekistan?
Provide a succinct answer. 9.34e+07. In the year 2001, what is the difference between the Aid flow (current US$) in Tanzania and Aid flow (current US$) in Uzbekistan?
Offer a terse response. 4.72e+07. In the year 2002, what is the difference between the Aid flow (current US$) in Other small states and Aid flow (current US$) in South Asia?
Provide a short and direct response. -5.41e+07. In the year 2002, what is the difference between the Aid flow (current US$) in Other small states and Aid flow (current US$) in Tanzania?
Keep it short and to the point. -4.42e+07. In the year 2002, what is the difference between the Aid flow (current US$) of Other small states and Aid flow (current US$) of Uzbekistan?
Give a very brief answer. 1.71e+07. In the year 2002, what is the difference between the Aid flow (current US$) in South Asia and Aid flow (current US$) in Tanzania?
Offer a terse response. 9.92e+06. In the year 2002, what is the difference between the Aid flow (current US$) of South Asia and Aid flow (current US$) of Uzbekistan?
Provide a succinct answer. 7.12e+07. In the year 2002, what is the difference between the Aid flow (current US$) of Tanzania and Aid flow (current US$) of Uzbekistan?
Ensure brevity in your answer.  6.13e+07. In the year 2003, what is the difference between the Aid flow (current US$) in Other small states and Aid flow (current US$) in South Asia?
Offer a terse response. -9.29e+07. In the year 2003, what is the difference between the Aid flow (current US$) of Other small states and Aid flow (current US$) of Tanzania?
Offer a very short reply. -4.69e+07. In the year 2003, what is the difference between the Aid flow (current US$) in Other small states and Aid flow (current US$) in Uzbekistan?
Make the answer very short. 1.91e+07. In the year 2003, what is the difference between the Aid flow (current US$) of South Asia and Aid flow (current US$) of Tanzania?
Provide a succinct answer. 4.60e+07. In the year 2003, what is the difference between the Aid flow (current US$) of South Asia and Aid flow (current US$) of Uzbekistan?
Offer a very short reply. 1.12e+08. In the year 2003, what is the difference between the Aid flow (current US$) in Tanzania and Aid flow (current US$) in Uzbekistan?
Provide a succinct answer. 6.60e+07. What is the ratio of the Aid flow (current US$) in Other small states in 1995 to that in 1997?
Offer a very short reply. 1.02. What is the ratio of the Aid flow (current US$) of South Asia in 1995 to that in 1997?
Offer a very short reply. 1.37. What is the ratio of the Aid flow (current US$) in Tanzania in 1995 to that in 1997?
Your answer should be compact. 0.94. What is the ratio of the Aid flow (current US$) in Other small states in 1995 to that in 1998?
Provide a succinct answer. 1.13. What is the ratio of the Aid flow (current US$) in South Asia in 1995 to that in 1998?
Give a very brief answer. 1.85. What is the ratio of the Aid flow (current US$) of Tanzania in 1995 to that in 1998?
Your answer should be very brief. 0.76. What is the ratio of the Aid flow (current US$) in Uzbekistan in 1995 to that in 1998?
Your answer should be compact. 0.3. What is the ratio of the Aid flow (current US$) in Other small states in 1995 to that in 1999?
Keep it short and to the point. 2.24. What is the ratio of the Aid flow (current US$) in South Asia in 1995 to that in 1999?
Your answer should be very brief. 1.85. What is the ratio of the Aid flow (current US$) of Tanzania in 1995 to that in 1999?
Offer a very short reply. 0.98. What is the ratio of the Aid flow (current US$) in Uzbekistan in 1995 to that in 1999?
Keep it short and to the point. 0.48. What is the ratio of the Aid flow (current US$) of Other small states in 1995 to that in 2000?
Offer a terse response. 1.29. What is the ratio of the Aid flow (current US$) of South Asia in 1995 to that in 2000?
Give a very brief answer. 1.54. What is the ratio of the Aid flow (current US$) of Tanzania in 1995 to that in 2000?
Keep it short and to the point. 0.71. What is the ratio of the Aid flow (current US$) of Uzbekistan in 1995 to that in 2000?
Ensure brevity in your answer.  0.88. What is the ratio of the Aid flow (current US$) of Other small states in 1995 to that in 2001?
Provide a succinct answer. 2.79. What is the ratio of the Aid flow (current US$) in South Asia in 1995 to that in 2001?
Give a very brief answer. 1.3. What is the ratio of the Aid flow (current US$) in Tanzania in 1995 to that in 2001?
Ensure brevity in your answer.  0.96. What is the ratio of the Aid flow (current US$) of Other small states in 1995 to that in 2002?
Provide a succinct answer. 2.29. What is the ratio of the Aid flow (current US$) of South Asia in 1995 to that in 2002?
Offer a terse response. 1.7. What is the ratio of the Aid flow (current US$) of Tanzania in 1995 to that in 2002?
Your answer should be very brief. 0.74. What is the ratio of the Aid flow (current US$) in Other small states in 1995 to that in 2003?
Make the answer very short. 2.05. What is the ratio of the Aid flow (current US$) of South Asia in 1995 to that in 2003?
Provide a succinct answer. 1.08. What is the ratio of the Aid flow (current US$) of Tanzania in 1995 to that in 2003?
Keep it short and to the point. 0.68. What is the ratio of the Aid flow (current US$) of Other small states in 1997 to that in 1998?
Make the answer very short. 1.11. What is the ratio of the Aid flow (current US$) of South Asia in 1997 to that in 1998?
Give a very brief answer. 1.35. What is the ratio of the Aid flow (current US$) of Tanzania in 1997 to that in 1998?
Offer a terse response. 0.81. What is the ratio of the Aid flow (current US$) in Uzbekistan in 1997 to that in 1998?
Keep it short and to the point. 0.28. What is the ratio of the Aid flow (current US$) of Other small states in 1997 to that in 1999?
Your answer should be very brief. 2.2. What is the ratio of the Aid flow (current US$) of South Asia in 1997 to that in 1999?
Provide a succinct answer. 1.35. What is the ratio of the Aid flow (current US$) in Tanzania in 1997 to that in 1999?
Provide a short and direct response. 1.04. What is the ratio of the Aid flow (current US$) in Uzbekistan in 1997 to that in 1999?
Offer a terse response. 0.45. What is the ratio of the Aid flow (current US$) of Other small states in 1997 to that in 2000?
Offer a terse response. 1.27. What is the ratio of the Aid flow (current US$) in South Asia in 1997 to that in 2000?
Keep it short and to the point. 1.12. What is the ratio of the Aid flow (current US$) in Tanzania in 1997 to that in 2000?
Offer a terse response. 0.76. What is the ratio of the Aid flow (current US$) in Uzbekistan in 1997 to that in 2000?
Your answer should be very brief. 0.81. What is the ratio of the Aid flow (current US$) of Other small states in 1997 to that in 2001?
Give a very brief answer. 2.74. What is the ratio of the Aid flow (current US$) of South Asia in 1997 to that in 2001?
Offer a terse response. 0.94. What is the ratio of the Aid flow (current US$) of Tanzania in 1997 to that in 2001?
Make the answer very short. 1.02. What is the ratio of the Aid flow (current US$) in Uzbekistan in 1997 to that in 2001?
Keep it short and to the point. 3.25. What is the ratio of the Aid flow (current US$) of Other small states in 1997 to that in 2002?
Provide a short and direct response. 2.25. What is the ratio of the Aid flow (current US$) of South Asia in 1997 to that in 2002?
Your answer should be compact. 1.23. What is the ratio of the Aid flow (current US$) of Tanzania in 1997 to that in 2002?
Provide a succinct answer. 0.78. What is the ratio of the Aid flow (current US$) in Other small states in 1997 to that in 2003?
Your response must be concise. 2.01. What is the ratio of the Aid flow (current US$) of South Asia in 1997 to that in 2003?
Your response must be concise. 0.79. What is the ratio of the Aid flow (current US$) in Tanzania in 1997 to that in 2003?
Your response must be concise. 0.73. What is the ratio of the Aid flow (current US$) of Other small states in 1998 to that in 1999?
Make the answer very short. 1.98. What is the ratio of the Aid flow (current US$) of Tanzania in 1998 to that in 1999?
Offer a terse response. 1.29. What is the ratio of the Aid flow (current US$) in Uzbekistan in 1998 to that in 1999?
Make the answer very short. 1.59. What is the ratio of the Aid flow (current US$) in Other small states in 1998 to that in 2000?
Your response must be concise. 1.14. What is the ratio of the Aid flow (current US$) of Tanzania in 1998 to that in 2000?
Your answer should be compact. 0.94. What is the ratio of the Aid flow (current US$) in Uzbekistan in 1998 to that in 2000?
Make the answer very short. 2.88. What is the ratio of the Aid flow (current US$) of Other small states in 1998 to that in 2001?
Your response must be concise. 2.47. What is the ratio of the Aid flow (current US$) of South Asia in 1998 to that in 2001?
Give a very brief answer. 0.7. What is the ratio of the Aid flow (current US$) in Tanzania in 1998 to that in 2001?
Make the answer very short. 1.27. What is the ratio of the Aid flow (current US$) of Uzbekistan in 1998 to that in 2001?
Your answer should be very brief. 11.5. What is the ratio of the Aid flow (current US$) of Other small states in 1998 to that in 2002?
Give a very brief answer. 2.03. What is the ratio of the Aid flow (current US$) of South Asia in 1998 to that in 2002?
Your response must be concise. 0.92. What is the ratio of the Aid flow (current US$) of Tanzania in 1998 to that in 2002?
Offer a very short reply. 0.97. What is the ratio of the Aid flow (current US$) in Uzbekistan in 1998 to that in 2002?
Offer a very short reply. 3.29. What is the ratio of the Aid flow (current US$) in Other small states in 1998 to that in 2003?
Keep it short and to the point. 1.81. What is the ratio of the Aid flow (current US$) in South Asia in 1998 to that in 2003?
Keep it short and to the point. 0.58. What is the ratio of the Aid flow (current US$) of Tanzania in 1998 to that in 2003?
Give a very brief answer. 0.9. What is the ratio of the Aid flow (current US$) in Uzbekistan in 1998 to that in 2003?
Offer a very short reply. 3.29. What is the ratio of the Aid flow (current US$) in Other small states in 1999 to that in 2000?
Your response must be concise. 0.58. What is the ratio of the Aid flow (current US$) of South Asia in 1999 to that in 2000?
Provide a short and direct response. 0.83. What is the ratio of the Aid flow (current US$) of Tanzania in 1999 to that in 2000?
Keep it short and to the point. 0.73. What is the ratio of the Aid flow (current US$) of Uzbekistan in 1999 to that in 2000?
Your answer should be very brief. 1.81. What is the ratio of the Aid flow (current US$) of Other small states in 1999 to that in 2001?
Your response must be concise. 1.25. What is the ratio of the Aid flow (current US$) in South Asia in 1999 to that in 2001?
Give a very brief answer. 0.7. What is the ratio of the Aid flow (current US$) in Tanzania in 1999 to that in 2001?
Provide a succinct answer. 0.98. What is the ratio of the Aid flow (current US$) of Uzbekistan in 1999 to that in 2001?
Your answer should be very brief. 7.25. What is the ratio of the Aid flow (current US$) of Other small states in 1999 to that in 2002?
Offer a very short reply. 1.02. What is the ratio of the Aid flow (current US$) of South Asia in 1999 to that in 2002?
Your answer should be very brief. 0.92. What is the ratio of the Aid flow (current US$) in Tanzania in 1999 to that in 2002?
Make the answer very short. 0.75. What is the ratio of the Aid flow (current US$) of Uzbekistan in 1999 to that in 2002?
Make the answer very short. 2.07. What is the ratio of the Aid flow (current US$) of Other small states in 1999 to that in 2003?
Offer a terse response. 0.91. What is the ratio of the Aid flow (current US$) in South Asia in 1999 to that in 2003?
Offer a terse response. 0.58. What is the ratio of the Aid flow (current US$) of Tanzania in 1999 to that in 2003?
Your answer should be compact. 0.7. What is the ratio of the Aid flow (current US$) of Uzbekistan in 1999 to that in 2003?
Your response must be concise. 2.07. What is the ratio of the Aid flow (current US$) in Other small states in 2000 to that in 2001?
Offer a very short reply. 2.16. What is the ratio of the Aid flow (current US$) of South Asia in 2000 to that in 2001?
Ensure brevity in your answer.  0.84. What is the ratio of the Aid flow (current US$) in Tanzania in 2000 to that in 2001?
Provide a succinct answer. 1.34. What is the ratio of the Aid flow (current US$) of Uzbekistan in 2000 to that in 2001?
Make the answer very short. 4. What is the ratio of the Aid flow (current US$) of Other small states in 2000 to that in 2002?
Provide a short and direct response. 1.77. What is the ratio of the Aid flow (current US$) in South Asia in 2000 to that in 2002?
Your answer should be compact. 1.1. What is the ratio of the Aid flow (current US$) in Tanzania in 2000 to that in 2002?
Your answer should be very brief. 1.03. What is the ratio of the Aid flow (current US$) of Other small states in 2000 to that in 2003?
Give a very brief answer. 1.58. What is the ratio of the Aid flow (current US$) in South Asia in 2000 to that in 2003?
Your response must be concise. 0.7. What is the ratio of the Aid flow (current US$) in Tanzania in 2000 to that in 2003?
Your answer should be very brief. 0.96. What is the ratio of the Aid flow (current US$) in Other small states in 2001 to that in 2002?
Offer a very short reply. 0.82. What is the ratio of the Aid flow (current US$) in South Asia in 2001 to that in 2002?
Keep it short and to the point. 1.31. What is the ratio of the Aid flow (current US$) in Tanzania in 2001 to that in 2002?
Provide a short and direct response. 0.77. What is the ratio of the Aid flow (current US$) in Uzbekistan in 2001 to that in 2002?
Offer a terse response. 0.29. What is the ratio of the Aid flow (current US$) of Other small states in 2001 to that in 2003?
Provide a short and direct response. 0.73. What is the ratio of the Aid flow (current US$) of South Asia in 2001 to that in 2003?
Offer a terse response. 0.83. What is the ratio of the Aid flow (current US$) in Uzbekistan in 2001 to that in 2003?
Offer a very short reply. 0.29. What is the ratio of the Aid flow (current US$) of Other small states in 2002 to that in 2003?
Provide a short and direct response. 0.89. What is the ratio of the Aid flow (current US$) of South Asia in 2002 to that in 2003?
Give a very brief answer. 0.64. What is the ratio of the Aid flow (current US$) of Tanzania in 2002 to that in 2003?
Your answer should be compact. 0.93. What is the ratio of the Aid flow (current US$) of Uzbekistan in 2002 to that in 2003?
Offer a very short reply. 1. What is the difference between the highest and the second highest Aid flow (current US$) of Other small states?
Offer a very short reply. 6.50e+05. What is the difference between the highest and the second highest Aid flow (current US$) in South Asia?
Offer a very short reply. 8.89e+06. What is the difference between the highest and the second highest Aid flow (current US$) of Tanzania?
Offer a terse response. 2.64e+06. What is the difference between the highest and the lowest Aid flow (current US$) of Other small states?
Your response must be concise. 2.53e+07. What is the difference between the highest and the lowest Aid flow (current US$) in South Asia?
Give a very brief answer. 5.57e+07. What is the difference between the highest and the lowest Aid flow (current US$) of Tanzania?
Your answer should be compact. 2.09e+07. 